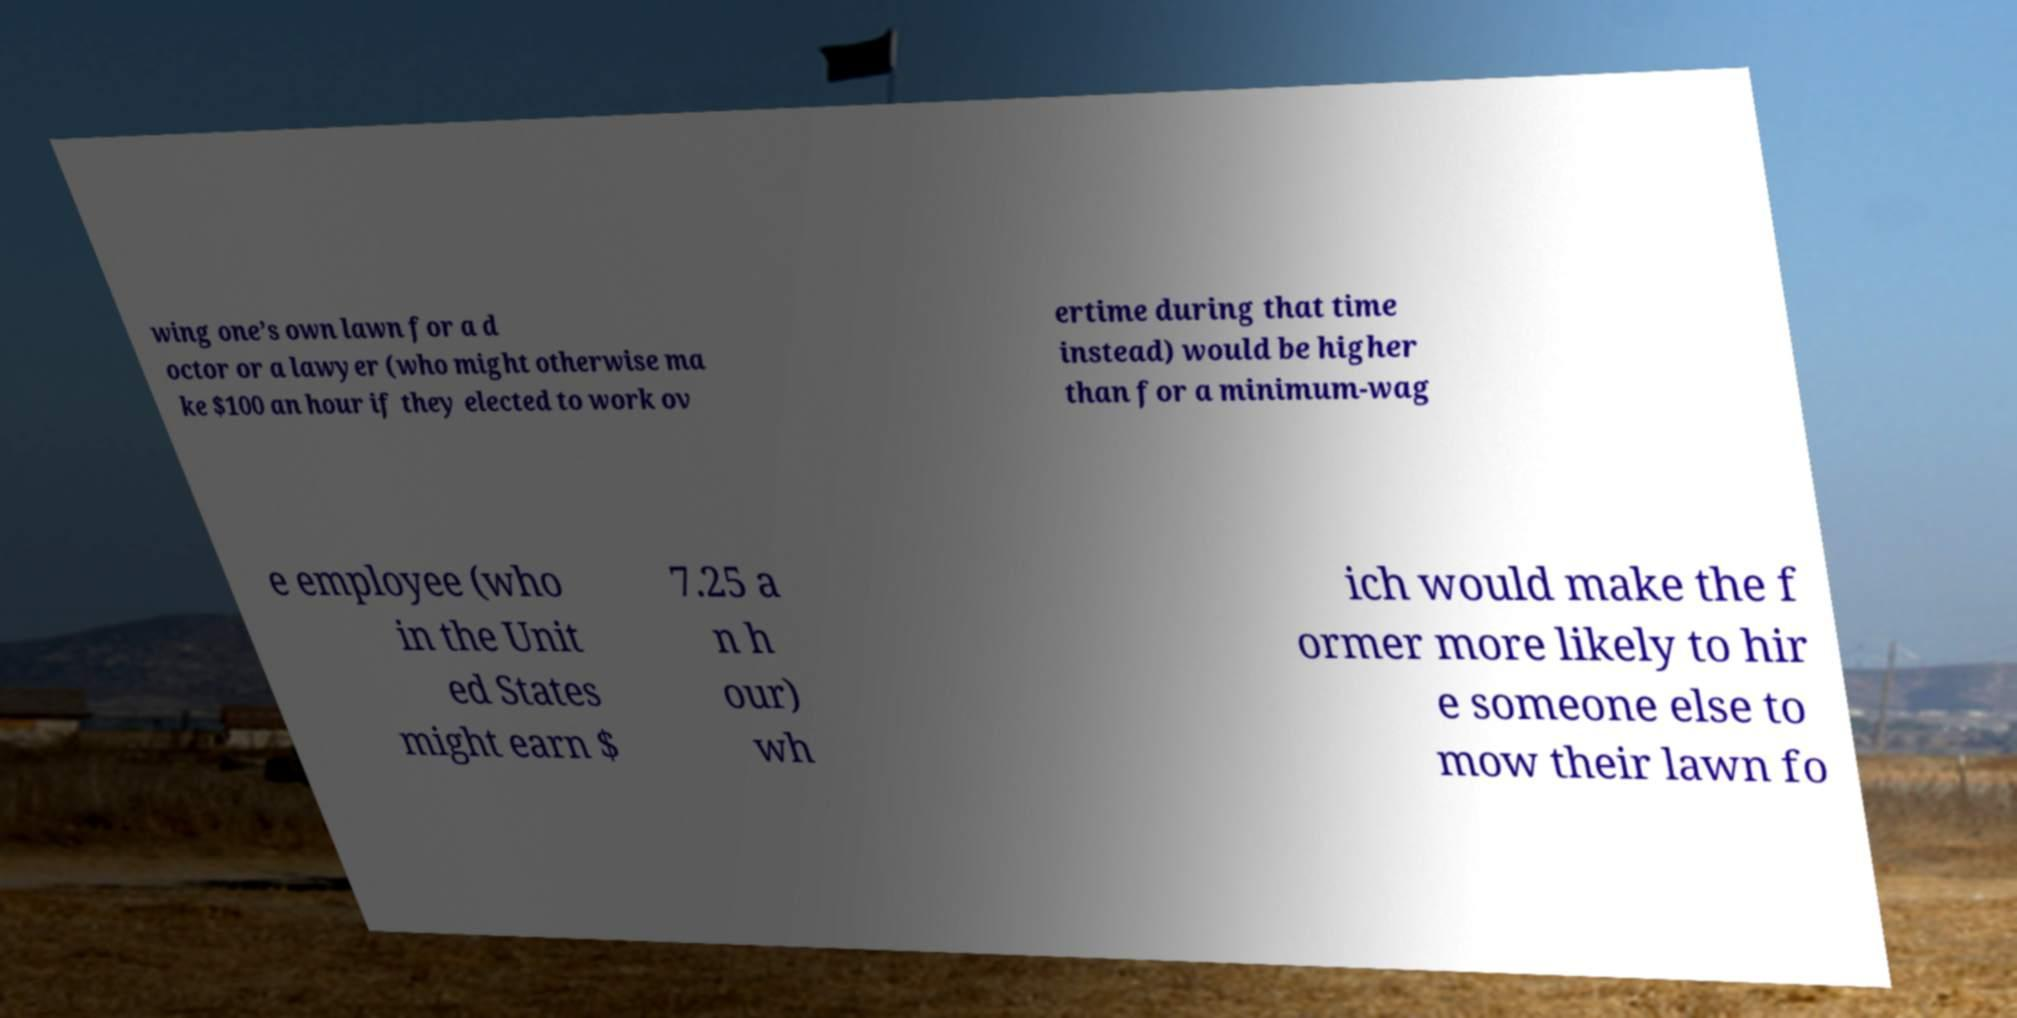Can you read and provide the text displayed in the image?This photo seems to have some interesting text. Can you extract and type it out for me? wing one’s own lawn for a d octor or a lawyer (who might otherwise ma ke $100 an hour if they elected to work ov ertime during that time instead) would be higher than for a minimum-wag e employee (who in the Unit ed States might earn $ 7.25 a n h our) wh ich would make the f ormer more likely to hir e someone else to mow their lawn fo 